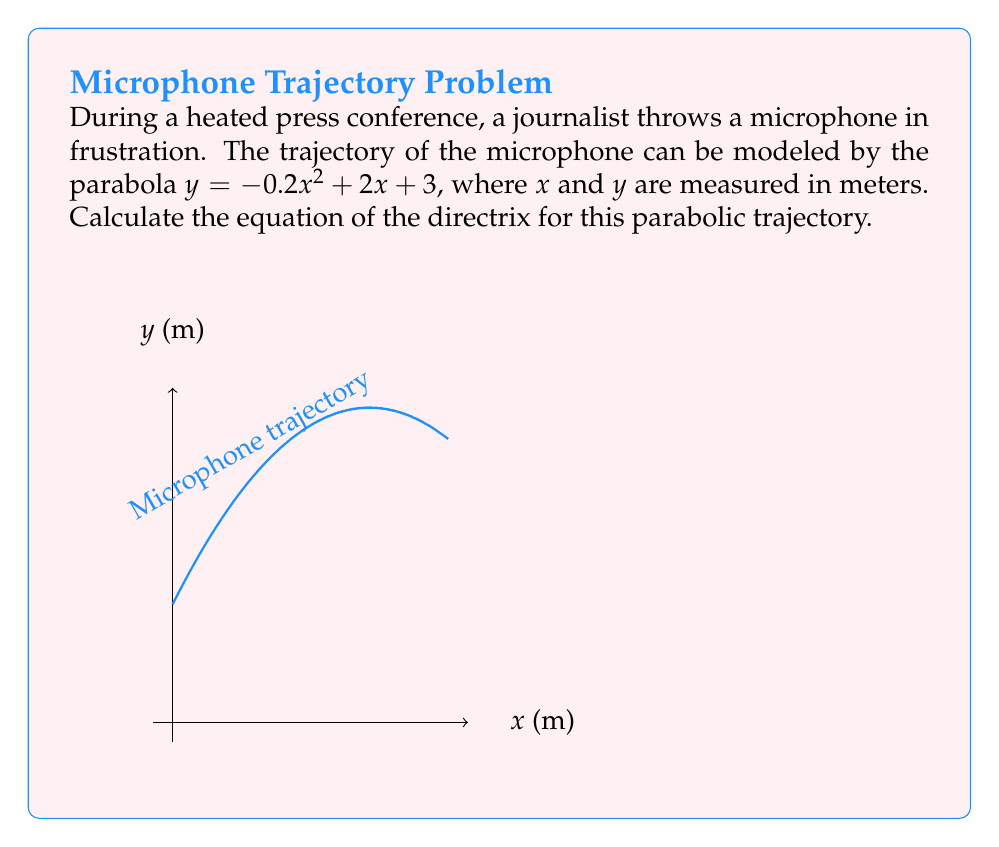Can you solve this math problem? Let's approach this step-by-step:

1) The general form of a parabola is $y = a(x-h)^2 + k$, where $(h,k)$ is the vertex and $a$ is the coefficient of $x^2$.

2) In our equation $y = -0.2x^2 + 2x + 3$, we have $a = -0.2$.

3) To find the vertex, we need to rewrite the equation in vertex form:
   $y = -0.2(x^2 - 10x) + 3$
   $y = -0.2(x^2 - 10x + 25 - 25) + 3$
   $y = -0.2(x - 5)^2 + 5 + 3$
   $y = -0.2(x - 5)^2 + 8$

4) So, the vertex is $(h, k) = (5, 8)$.

5) For a parabola with equation $y = a(x-h)^2 + k$, the distance from the vertex to the directrix is $\frac{1}{4a}$.

6) In this case, $\frac{1}{4a} = \frac{1}{4(-0.2)} = -\frac{5}{4} = -1.25$

7) Since the parabola opens downward ($a$ is negative), the directrix is 1.25 meters above the vertex.

8) The y-coordinate of the directrix is therefore $8 + 1.25 = 9.25$

9) The equation of the directrix is $y = 9.25$
Answer: $y = 9.25$ 